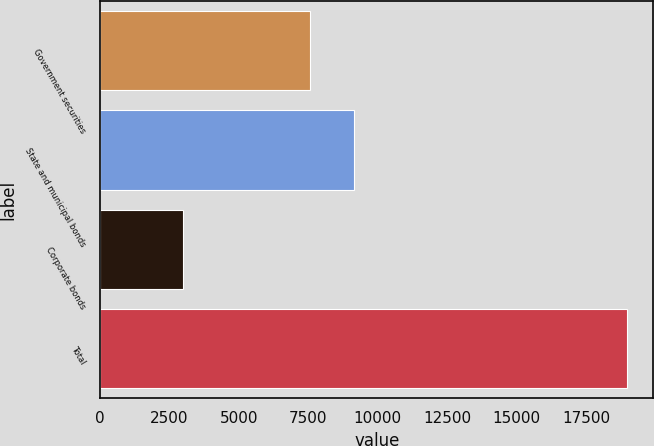Convert chart. <chart><loc_0><loc_0><loc_500><loc_500><bar_chart><fcel>Government securities<fcel>State and municipal bonds<fcel>Corporate bonds<fcel>Total<nl><fcel>7561<fcel>9157.7<fcel>3000<fcel>18967<nl></chart> 